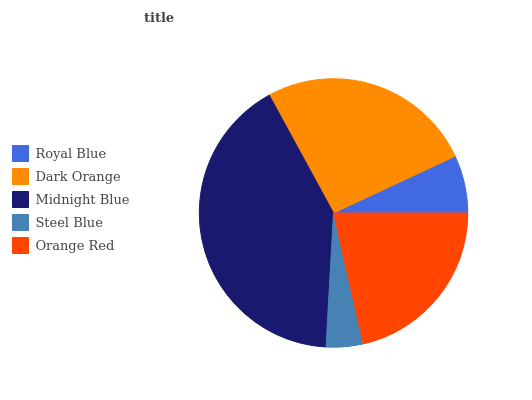Is Steel Blue the minimum?
Answer yes or no. Yes. Is Midnight Blue the maximum?
Answer yes or no. Yes. Is Dark Orange the minimum?
Answer yes or no. No. Is Dark Orange the maximum?
Answer yes or no. No. Is Dark Orange greater than Royal Blue?
Answer yes or no. Yes. Is Royal Blue less than Dark Orange?
Answer yes or no. Yes. Is Royal Blue greater than Dark Orange?
Answer yes or no. No. Is Dark Orange less than Royal Blue?
Answer yes or no. No. Is Orange Red the high median?
Answer yes or no. Yes. Is Orange Red the low median?
Answer yes or no. Yes. Is Steel Blue the high median?
Answer yes or no. No. Is Dark Orange the low median?
Answer yes or no. No. 